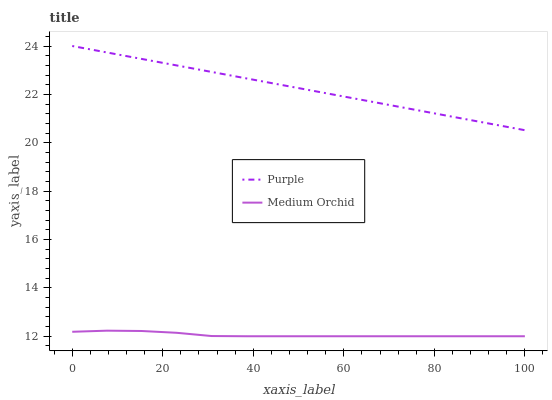Does Medium Orchid have the maximum area under the curve?
Answer yes or no. No. Is Medium Orchid the smoothest?
Answer yes or no. No. Does Medium Orchid have the highest value?
Answer yes or no. No. Is Medium Orchid less than Purple?
Answer yes or no. Yes. Is Purple greater than Medium Orchid?
Answer yes or no. Yes. Does Medium Orchid intersect Purple?
Answer yes or no. No. 